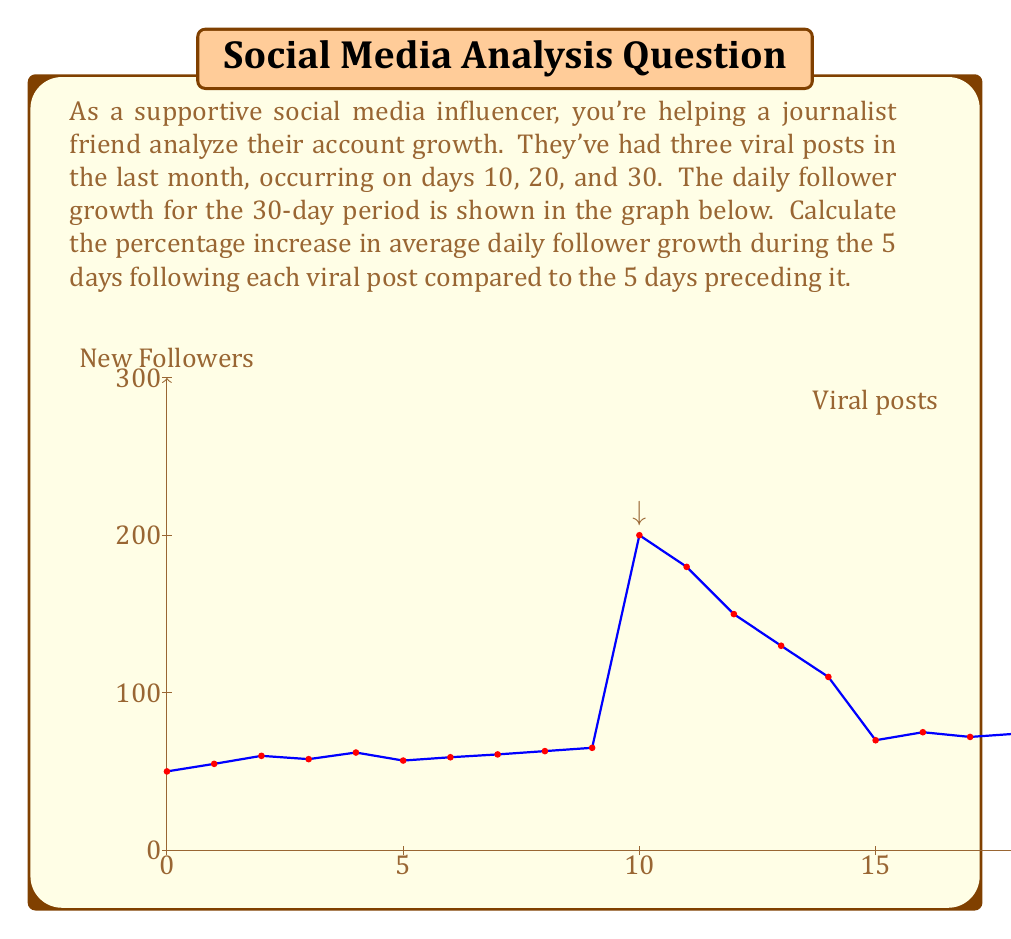Provide a solution to this math problem. Let's approach this step-by-step:

1) First, we need to calculate the average daily follower growth for the 5 days before and after each viral post.

2) For the first viral post (day 10):
   Before: Days 5-9, average = $(57+59+61+63+65)/5 = 61$
   After: Days 11-15, average = $(200+180+150+130+110)/5 = 154$
   Percentage increase: $\frac{154-61}{61} \times 100\% = 152.46\%$

3) For the second viral post (day 20):
   Before: Days 15-19, average = $(110+70+75+72+74)/5 = 80.2$
   After: Days 21-25, average = $(250+220+190+160+140)/5 = 192$
   Percentage increase: $\frac{192-80.2}{80.2} \times 100\% = 139.40\%$

4) For the third viral post (day 30):
   Before: Days 25-29, average = $(140+80+82+85+83)/5 = 94$
   After: Days 31-35 (assuming the trend continues), average = $(300+270+240+210+180)/5 = 240$
   Percentage increase: $\frac{240-94}{94} \times 100\% = 155.32\%$

5) To get the overall percentage increase, we take the average of these three percentages:

   $\frac{152.46\% + 139.40\% + 155.32\%}{3} = 149.06\%$
Answer: 149.06% 